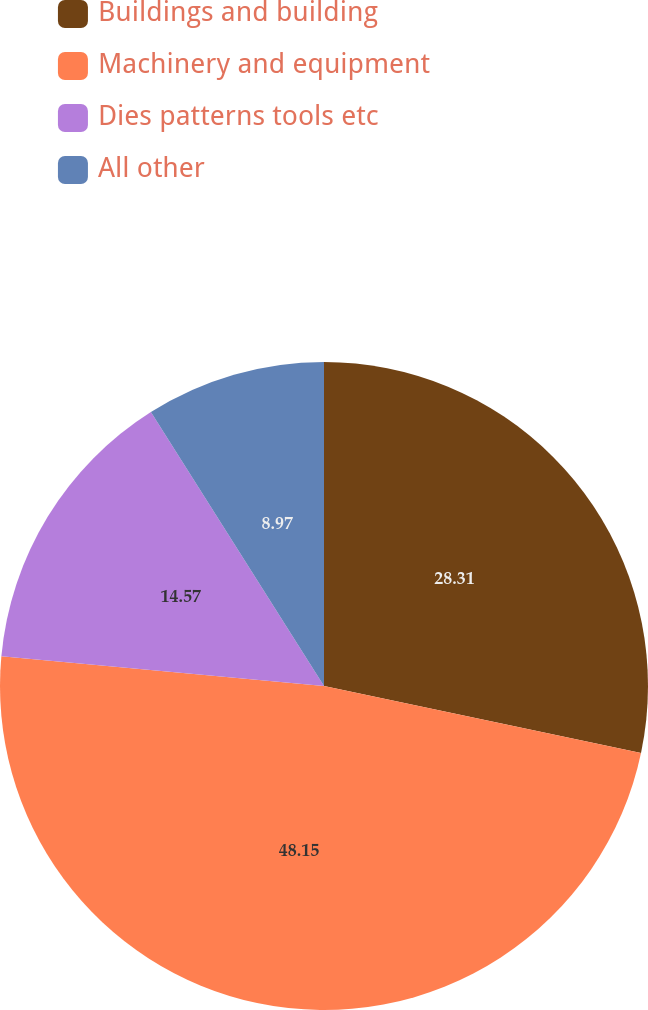Convert chart to OTSL. <chart><loc_0><loc_0><loc_500><loc_500><pie_chart><fcel>Buildings and building<fcel>Machinery and equipment<fcel>Dies patterns tools etc<fcel>All other<nl><fcel>28.31%<fcel>48.14%<fcel>14.57%<fcel>8.97%<nl></chart> 